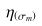Convert formula to latex. <formula><loc_0><loc_0><loc_500><loc_500>\eta _ { ( \sigma _ { m } ) }</formula> 